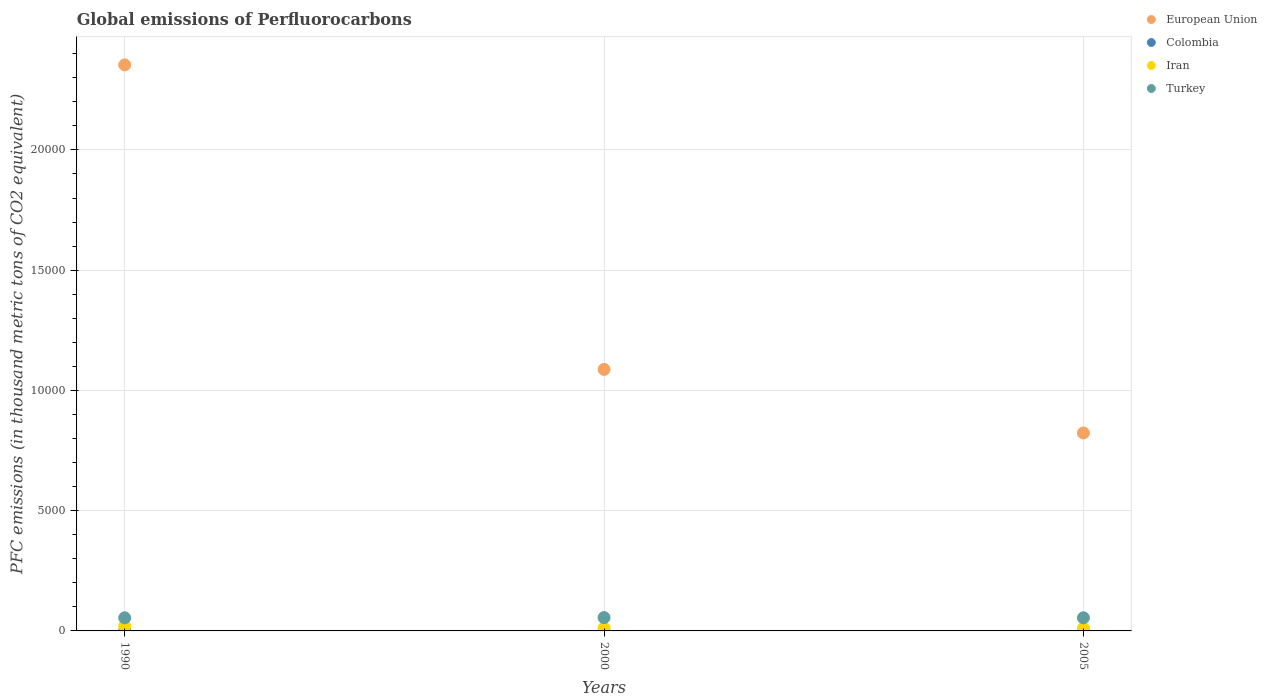Is the number of dotlines equal to the number of legend labels?
Your answer should be compact. Yes. What is the global emissions of Perfluorocarbons in Turkey in 2000?
Make the answer very short. 554.9. Across all years, what is the maximum global emissions of Perfluorocarbons in Colombia?
Ensure brevity in your answer.  0.2. Across all years, what is the minimum global emissions of Perfluorocarbons in European Union?
Offer a very short reply. 8230.79. In which year was the global emissions of Perfluorocarbons in Colombia minimum?
Ensure brevity in your answer.  1990. What is the total global emissions of Perfluorocarbons in Turkey in the graph?
Keep it short and to the point. 1646.4. What is the difference between the global emissions of Perfluorocarbons in European Union in 1990 and that in 2000?
Your answer should be compact. 1.27e+04. What is the difference between the global emissions of Perfluorocarbons in Colombia in 1990 and the global emissions of Perfluorocarbons in European Union in 2000?
Your answer should be compact. -1.09e+04. What is the average global emissions of Perfluorocarbons in European Union per year?
Keep it short and to the point. 1.42e+04. In the year 2000, what is the difference between the global emissions of Perfluorocarbons in Colombia and global emissions of Perfluorocarbons in European Union?
Provide a succinct answer. -1.09e+04. In how many years, is the global emissions of Perfluorocarbons in Iran greater than 16000 thousand metric tons?
Your answer should be very brief. 0. What is the ratio of the global emissions of Perfluorocarbons in Iran in 1990 to that in 2005?
Your answer should be very brief. 1.88. Is the global emissions of Perfluorocarbons in Iran in 1990 less than that in 2005?
Your answer should be very brief. No. What is the difference between the highest and the second highest global emissions of Perfluorocarbons in European Union?
Provide a short and direct response. 1.27e+04. Is the sum of the global emissions of Perfluorocarbons in Turkey in 1990 and 2000 greater than the maximum global emissions of Perfluorocarbons in Iran across all years?
Your answer should be compact. Yes. Is it the case that in every year, the sum of the global emissions of Perfluorocarbons in Colombia and global emissions of Perfluorocarbons in European Union  is greater than the sum of global emissions of Perfluorocarbons in Iran and global emissions of Perfluorocarbons in Turkey?
Keep it short and to the point. No. Is it the case that in every year, the sum of the global emissions of Perfluorocarbons in European Union and global emissions of Perfluorocarbons in Turkey  is greater than the global emissions of Perfluorocarbons in Colombia?
Your response must be concise. Yes. Does the global emissions of Perfluorocarbons in Iran monotonically increase over the years?
Make the answer very short. No. How many dotlines are there?
Provide a short and direct response. 4. How many years are there in the graph?
Your response must be concise. 3. What is the difference between two consecutive major ticks on the Y-axis?
Provide a short and direct response. 5000. Are the values on the major ticks of Y-axis written in scientific E-notation?
Offer a very short reply. No. How many legend labels are there?
Your response must be concise. 4. What is the title of the graph?
Provide a succinct answer. Global emissions of Perfluorocarbons. Does "Burundi" appear as one of the legend labels in the graph?
Give a very brief answer. No. What is the label or title of the Y-axis?
Your answer should be very brief. PFC emissions (in thousand metric tons of CO2 equivalent). What is the PFC emissions (in thousand metric tons of CO2 equivalent) in European Union in 1990?
Provide a succinct answer. 2.35e+04. What is the PFC emissions (in thousand metric tons of CO2 equivalent) in Colombia in 1990?
Make the answer very short. 0.2. What is the PFC emissions (in thousand metric tons of CO2 equivalent) in Iran in 1990?
Make the answer very short. 203.5. What is the PFC emissions (in thousand metric tons of CO2 equivalent) in Turkey in 1990?
Your response must be concise. 545.6. What is the PFC emissions (in thousand metric tons of CO2 equivalent) in European Union in 2000?
Ensure brevity in your answer.  1.09e+04. What is the PFC emissions (in thousand metric tons of CO2 equivalent) of Iran in 2000?
Offer a terse response. 128.5. What is the PFC emissions (in thousand metric tons of CO2 equivalent) in Turkey in 2000?
Give a very brief answer. 554.9. What is the PFC emissions (in thousand metric tons of CO2 equivalent) of European Union in 2005?
Provide a short and direct response. 8230.79. What is the PFC emissions (in thousand metric tons of CO2 equivalent) in Colombia in 2005?
Your answer should be very brief. 0.2. What is the PFC emissions (in thousand metric tons of CO2 equivalent) in Iran in 2005?
Your answer should be compact. 108.5. What is the PFC emissions (in thousand metric tons of CO2 equivalent) of Turkey in 2005?
Your answer should be very brief. 545.9. Across all years, what is the maximum PFC emissions (in thousand metric tons of CO2 equivalent) in European Union?
Give a very brief answer. 2.35e+04. Across all years, what is the maximum PFC emissions (in thousand metric tons of CO2 equivalent) in Colombia?
Your response must be concise. 0.2. Across all years, what is the maximum PFC emissions (in thousand metric tons of CO2 equivalent) of Iran?
Give a very brief answer. 203.5. Across all years, what is the maximum PFC emissions (in thousand metric tons of CO2 equivalent) of Turkey?
Your answer should be compact. 554.9. Across all years, what is the minimum PFC emissions (in thousand metric tons of CO2 equivalent) in European Union?
Your response must be concise. 8230.79. Across all years, what is the minimum PFC emissions (in thousand metric tons of CO2 equivalent) of Colombia?
Your answer should be compact. 0.2. Across all years, what is the minimum PFC emissions (in thousand metric tons of CO2 equivalent) in Iran?
Provide a short and direct response. 108.5. Across all years, what is the minimum PFC emissions (in thousand metric tons of CO2 equivalent) of Turkey?
Ensure brevity in your answer.  545.6. What is the total PFC emissions (in thousand metric tons of CO2 equivalent) of European Union in the graph?
Provide a short and direct response. 4.26e+04. What is the total PFC emissions (in thousand metric tons of CO2 equivalent) in Colombia in the graph?
Offer a terse response. 0.6. What is the total PFC emissions (in thousand metric tons of CO2 equivalent) of Iran in the graph?
Ensure brevity in your answer.  440.5. What is the total PFC emissions (in thousand metric tons of CO2 equivalent) in Turkey in the graph?
Your answer should be very brief. 1646.4. What is the difference between the PFC emissions (in thousand metric tons of CO2 equivalent) in European Union in 1990 and that in 2000?
Make the answer very short. 1.27e+04. What is the difference between the PFC emissions (in thousand metric tons of CO2 equivalent) in Colombia in 1990 and that in 2000?
Your answer should be very brief. 0. What is the difference between the PFC emissions (in thousand metric tons of CO2 equivalent) of European Union in 1990 and that in 2005?
Your response must be concise. 1.53e+04. What is the difference between the PFC emissions (in thousand metric tons of CO2 equivalent) in European Union in 2000 and that in 2005?
Your answer should be compact. 2643.81. What is the difference between the PFC emissions (in thousand metric tons of CO2 equivalent) in Colombia in 2000 and that in 2005?
Make the answer very short. 0. What is the difference between the PFC emissions (in thousand metric tons of CO2 equivalent) of Turkey in 2000 and that in 2005?
Ensure brevity in your answer.  9. What is the difference between the PFC emissions (in thousand metric tons of CO2 equivalent) in European Union in 1990 and the PFC emissions (in thousand metric tons of CO2 equivalent) in Colombia in 2000?
Keep it short and to the point. 2.35e+04. What is the difference between the PFC emissions (in thousand metric tons of CO2 equivalent) in European Union in 1990 and the PFC emissions (in thousand metric tons of CO2 equivalent) in Iran in 2000?
Make the answer very short. 2.34e+04. What is the difference between the PFC emissions (in thousand metric tons of CO2 equivalent) of European Union in 1990 and the PFC emissions (in thousand metric tons of CO2 equivalent) of Turkey in 2000?
Offer a terse response. 2.30e+04. What is the difference between the PFC emissions (in thousand metric tons of CO2 equivalent) of Colombia in 1990 and the PFC emissions (in thousand metric tons of CO2 equivalent) of Iran in 2000?
Your answer should be very brief. -128.3. What is the difference between the PFC emissions (in thousand metric tons of CO2 equivalent) in Colombia in 1990 and the PFC emissions (in thousand metric tons of CO2 equivalent) in Turkey in 2000?
Offer a terse response. -554.7. What is the difference between the PFC emissions (in thousand metric tons of CO2 equivalent) of Iran in 1990 and the PFC emissions (in thousand metric tons of CO2 equivalent) of Turkey in 2000?
Ensure brevity in your answer.  -351.4. What is the difference between the PFC emissions (in thousand metric tons of CO2 equivalent) in European Union in 1990 and the PFC emissions (in thousand metric tons of CO2 equivalent) in Colombia in 2005?
Your response must be concise. 2.35e+04. What is the difference between the PFC emissions (in thousand metric tons of CO2 equivalent) in European Union in 1990 and the PFC emissions (in thousand metric tons of CO2 equivalent) in Iran in 2005?
Give a very brief answer. 2.34e+04. What is the difference between the PFC emissions (in thousand metric tons of CO2 equivalent) of European Union in 1990 and the PFC emissions (in thousand metric tons of CO2 equivalent) of Turkey in 2005?
Your response must be concise. 2.30e+04. What is the difference between the PFC emissions (in thousand metric tons of CO2 equivalent) in Colombia in 1990 and the PFC emissions (in thousand metric tons of CO2 equivalent) in Iran in 2005?
Your answer should be very brief. -108.3. What is the difference between the PFC emissions (in thousand metric tons of CO2 equivalent) of Colombia in 1990 and the PFC emissions (in thousand metric tons of CO2 equivalent) of Turkey in 2005?
Offer a terse response. -545.7. What is the difference between the PFC emissions (in thousand metric tons of CO2 equivalent) in Iran in 1990 and the PFC emissions (in thousand metric tons of CO2 equivalent) in Turkey in 2005?
Your answer should be very brief. -342.4. What is the difference between the PFC emissions (in thousand metric tons of CO2 equivalent) of European Union in 2000 and the PFC emissions (in thousand metric tons of CO2 equivalent) of Colombia in 2005?
Give a very brief answer. 1.09e+04. What is the difference between the PFC emissions (in thousand metric tons of CO2 equivalent) of European Union in 2000 and the PFC emissions (in thousand metric tons of CO2 equivalent) of Iran in 2005?
Keep it short and to the point. 1.08e+04. What is the difference between the PFC emissions (in thousand metric tons of CO2 equivalent) of European Union in 2000 and the PFC emissions (in thousand metric tons of CO2 equivalent) of Turkey in 2005?
Your answer should be very brief. 1.03e+04. What is the difference between the PFC emissions (in thousand metric tons of CO2 equivalent) in Colombia in 2000 and the PFC emissions (in thousand metric tons of CO2 equivalent) in Iran in 2005?
Ensure brevity in your answer.  -108.3. What is the difference between the PFC emissions (in thousand metric tons of CO2 equivalent) of Colombia in 2000 and the PFC emissions (in thousand metric tons of CO2 equivalent) of Turkey in 2005?
Ensure brevity in your answer.  -545.7. What is the difference between the PFC emissions (in thousand metric tons of CO2 equivalent) in Iran in 2000 and the PFC emissions (in thousand metric tons of CO2 equivalent) in Turkey in 2005?
Your response must be concise. -417.4. What is the average PFC emissions (in thousand metric tons of CO2 equivalent) of European Union per year?
Your response must be concise. 1.42e+04. What is the average PFC emissions (in thousand metric tons of CO2 equivalent) of Colombia per year?
Offer a very short reply. 0.2. What is the average PFC emissions (in thousand metric tons of CO2 equivalent) in Iran per year?
Offer a terse response. 146.83. What is the average PFC emissions (in thousand metric tons of CO2 equivalent) in Turkey per year?
Your response must be concise. 548.8. In the year 1990, what is the difference between the PFC emissions (in thousand metric tons of CO2 equivalent) in European Union and PFC emissions (in thousand metric tons of CO2 equivalent) in Colombia?
Make the answer very short. 2.35e+04. In the year 1990, what is the difference between the PFC emissions (in thousand metric tons of CO2 equivalent) of European Union and PFC emissions (in thousand metric tons of CO2 equivalent) of Iran?
Keep it short and to the point. 2.33e+04. In the year 1990, what is the difference between the PFC emissions (in thousand metric tons of CO2 equivalent) in European Union and PFC emissions (in thousand metric tons of CO2 equivalent) in Turkey?
Keep it short and to the point. 2.30e+04. In the year 1990, what is the difference between the PFC emissions (in thousand metric tons of CO2 equivalent) of Colombia and PFC emissions (in thousand metric tons of CO2 equivalent) of Iran?
Offer a very short reply. -203.3. In the year 1990, what is the difference between the PFC emissions (in thousand metric tons of CO2 equivalent) in Colombia and PFC emissions (in thousand metric tons of CO2 equivalent) in Turkey?
Ensure brevity in your answer.  -545.4. In the year 1990, what is the difference between the PFC emissions (in thousand metric tons of CO2 equivalent) in Iran and PFC emissions (in thousand metric tons of CO2 equivalent) in Turkey?
Your response must be concise. -342.1. In the year 2000, what is the difference between the PFC emissions (in thousand metric tons of CO2 equivalent) of European Union and PFC emissions (in thousand metric tons of CO2 equivalent) of Colombia?
Offer a terse response. 1.09e+04. In the year 2000, what is the difference between the PFC emissions (in thousand metric tons of CO2 equivalent) of European Union and PFC emissions (in thousand metric tons of CO2 equivalent) of Iran?
Your answer should be very brief. 1.07e+04. In the year 2000, what is the difference between the PFC emissions (in thousand metric tons of CO2 equivalent) in European Union and PFC emissions (in thousand metric tons of CO2 equivalent) in Turkey?
Offer a very short reply. 1.03e+04. In the year 2000, what is the difference between the PFC emissions (in thousand metric tons of CO2 equivalent) of Colombia and PFC emissions (in thousand metric tons of CO2 equivalent) of Iran?
Give a very brief answer. -128.3. In the year 2000, what is the difference between the PFC emissions (in thousand metric tons of CO2 equivalent) of Colombia and PFC emissions (in thousand metric tons of CO2 equivalent) of Turkey?
Give a very brief answer. -554.7. In the year 2000, what is the difference between the PFC emissions (in thousand metric tons of CO2 equivalent) of Iran and PFC emissions (in thousand metric tons of CO2 equivalent) of Turkey?
Your answer should be compact. -426.4. In the year 2005, what is the difference between the PFC emissions (in thousand metric tons of CO2 equivalent) of European Union and PFC emissions (in thousand metric tons of CO2 equivalent) of Colombia?
Your response must be concise. 8230.59. In the year 2005, what is the difference between the PFC emissions (in thousand metric tons of CO2 equivalent) in European Union and PFC emissions (in thousand metric tons of CO2 equivalent) in Iran?
Your answer should be very brief. 8122.29. In the year 2005, what is the difference between the PFC emissions (in thousand metric tons of CO2 equivalent) of European Union and PFC emissions (in thousand metric tons of CO2 equivalent) of Turkey?
Your answer should be very brief. 7684.89. In the year 2005, what is the difference between the PFC emissions (in thousand metric tons of CO2 equivalent) of Colombia and PFC emissions (in thousand metric tons of CO2 equivalent) of Iran?
Offer a terse response. -108.3. In the year 2005, what is the difference between the PFC emissions (in thousand metric tons of CO2 equivalent) of Colombia and PFC emissions (in thousand metric tons of CO2 equivalent) of Turkey?
Provide a short and direct response. -545.7. In the year 2005, what is the difference between the PFC emissions (in thousand metric tons of CO2 equivalent) in Iran and PFC emissions (in thousand metric tons of CO2 equivalent) in Turkey?
Offer a very short reply. -437.4. What is the ratio of the PFC emissions (in thousand metric tons of CO2 equivalent) of European Union in 1990 to that in 2000?
Offer a terse response. 2.16. What is the ratio of the PFC emissions (in thousand metric tons of CO2 equivalent) of Iran in 1990 to that in 2000?
Provide a short and direct response. 1.58. What is the ratio of the PFC emissions (in thousand metric tons of CO2 equivalent) of Turkey in 1990 to that in 2000?
Offer a terse response. 0.98. What is the ratio of the PFC emissions (in thousand metric tons of CO2 equivalent) in European Union in 1990 to that in 2005?
Provide a succinct answer. 2.86. What is the ratio of the PFC emissions (in thousand metric tons of CO2 equivalent) of Iran in 1990 to that in 2005?
Give a very brief answer. 1.88. What is the ratio of the PFC emissions (in thousand metric tons of CO2 equivalent) in Turkey in 1990 to that in 2005?
Keep it short and to the point. 1. What is the ratio of the PFC emissions (in thousand metric tons of CO2 equivalent) of European Union in 2000 to that in 2005?
Your answer should be very brief. 1.32. What is the ratio of the PFC emissions (in thousand metric tons of CO2 equivalent) of Iran in 2000 to that in 2005?
Keep it short and to the point. 1.18. What is the ratio of the PFC emissions (in thousand metric tons of CO2 equivalent) in Turkey in 2000 to that in 2005?
Your response must be concise. 1.02. What is the difference between the highest and the second highest PFC emissions (in thousand metric tons of CO2 equivalent) in European Union?
Provide a succinct answer. 1.27e+04. What is the difference between the highest and the lowest PFC emissions (in thousand metric tons of CO2 equivalent) in European Union?
Your answer should be very brief. 1.53e+04. 